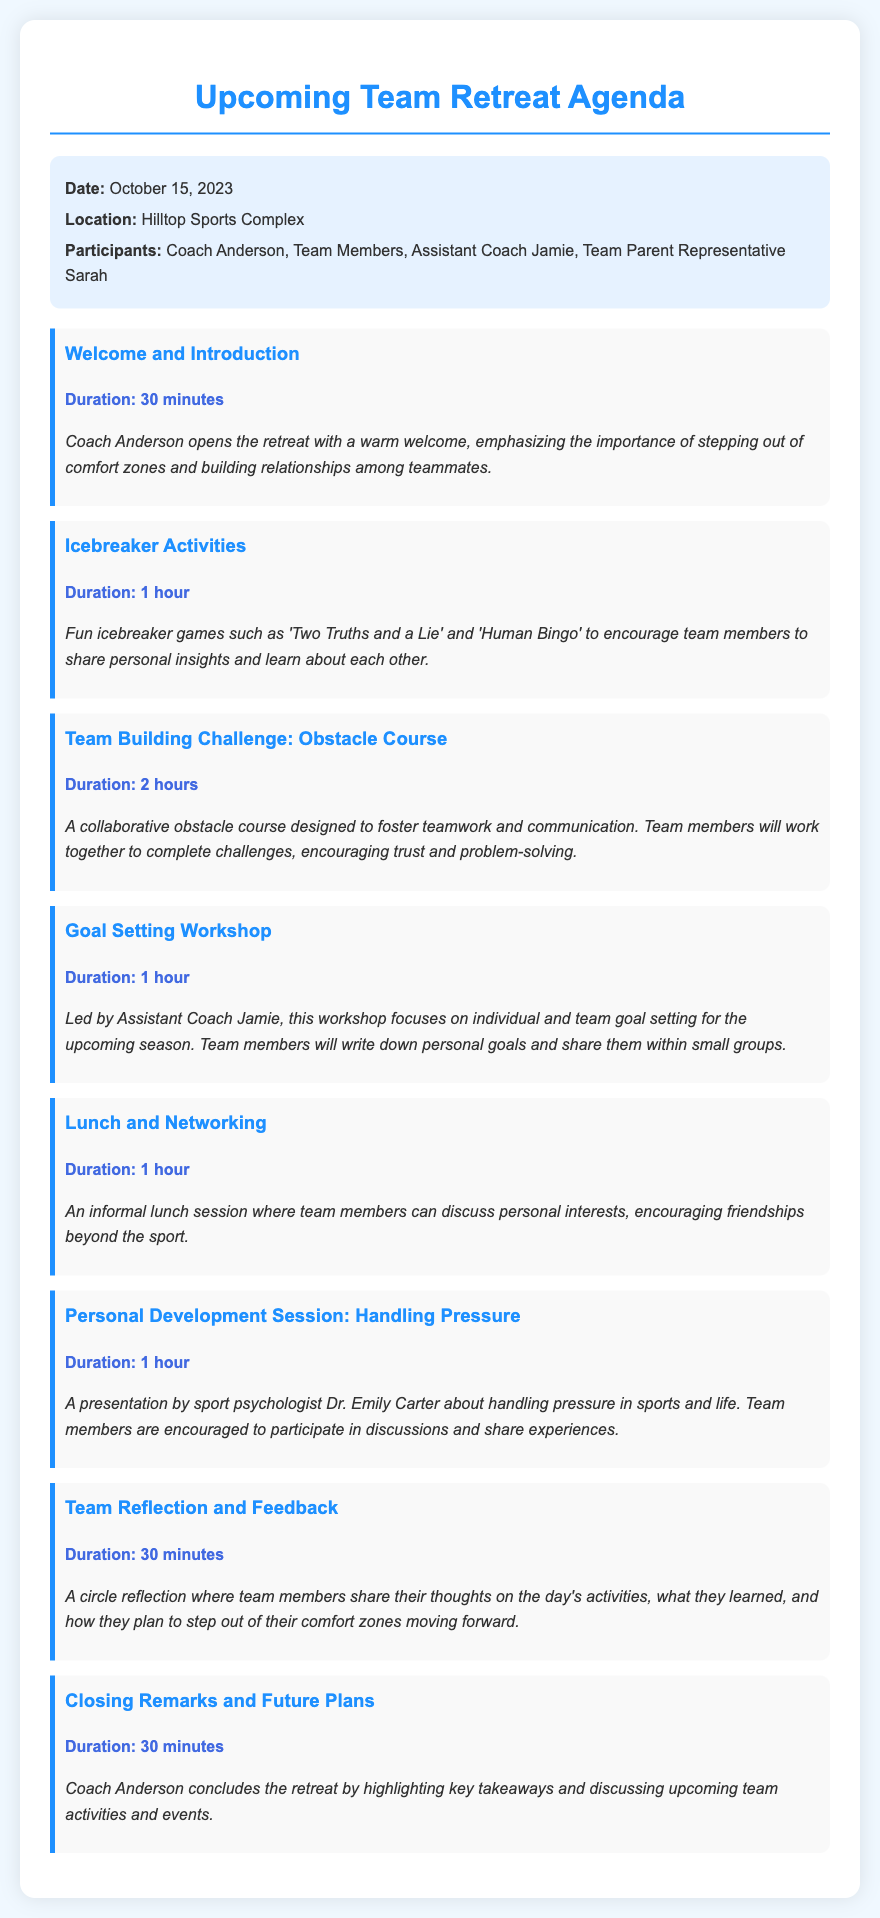What is the date of the team retreat? The date of the team retreat is specified in the document under the info section.
Answer: October 15, 2023 Where is the retreat taking place? The location of the team retreat is mentioned in the info section of the document.
Answer: Hilltop Sports Complex Who is leading the Goal Setting Workshop? The document states who is leading the workshop under that agenda item.
Answer: Assistant Coach Jamie What is one of the icebreaker activities mentioned? The icebreaker activities section lists specific games that will be played.
Answer: Human Bingo How long is the Team Building Challenge? The duration of the Team Building Challenge is specified in the details of that agenda item.
Answer: 2 hours What is the focus of the Personal Development Session? The purpose of the Personal Development Session is found in its details.
Answer: Handling Pressure What activity encourages personal discussions over lunch? The lunch agenda item indicates it as a networking opportunity.
Answer: Lunch and Networking How will team members share their reflections at the end? The final agenda item mentions how team reflections will take place.
Answer: Circle reflection 